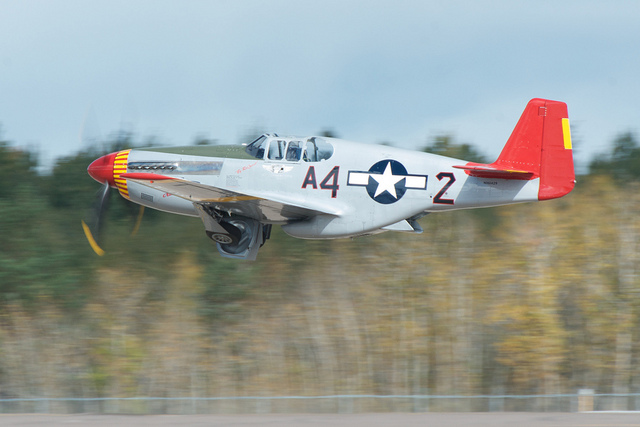Can you tell me the historical significance of the aircraft in the image? The aircraft is a P-51 Mustang, a renowned fighter used primarily during World War II. It played a significant role in the air battles of the war and is revered for its performance and impact on the outcome of aerial combat. 